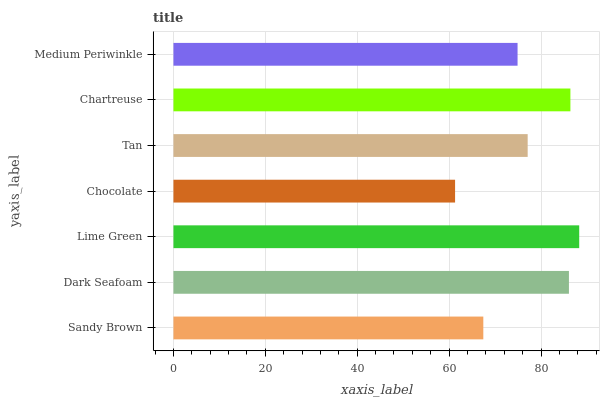Is Chocolate the minimum?
Answer yes or no. Yes. Is Lime Green the maximum?
Answer yes or no. Yes. Is Dark Seafoam the minimum?
Answer yes or no. No. Is Dark Seafoam the maximum?
Answer yes or no. No. Is Dark Seafoam greater than Sandy Brown?
Answer yes or no. Yes. Is Sandy Brown less than Dark Seafoam?
Answer yes or no. Yes. Is Sandy Brown greater than Dark Seafoam?
Answer yes or no. No. Is Dark Seafoam less than Sandy Brown?
Answer yes or no. No. Is Tan the high median?
Answer yes or no. Yes. Is Tan the low median?
Answer yes or no. Yes. Is Chocolate the high median?
Answer yes or no. No. Is Lime Green the low median?
Answer yes or no. No. 